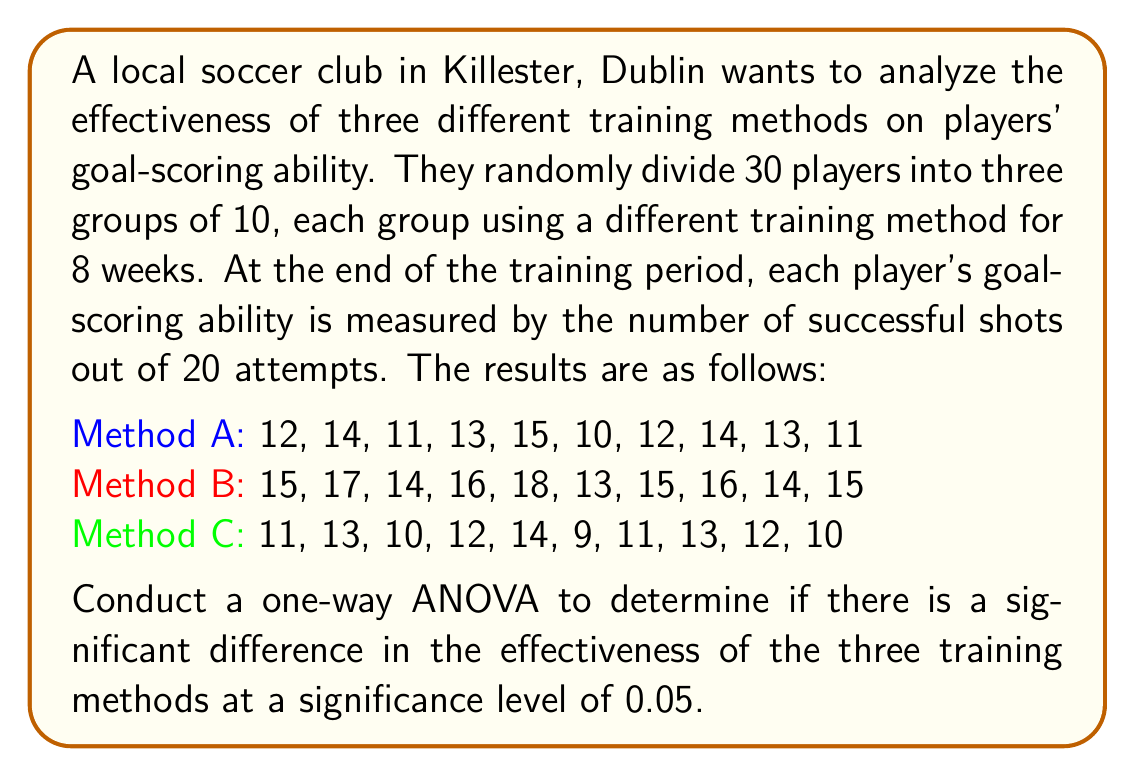What is the answer to this math problem? To conduct a one-way ANOVA, we'll follow these steps:

1. Calculate the sum of squares between groups (SSB), within groups (SSW), and total (SST).
2. Calculate the degrees of freedom for between groups (dfB), within groups (dfW), and total (dfT).
3. Calculate the mean squares for between groups (MSB) and within groups (MSW).
4. Calculate the F-statistic.
5. Compare the F-statistic to the critical F-value.

Step 1: Calculate sums of squares

First, we need to calculate the grand mean:
$$ \bar{X} = \frac{(12+14+...+10) + (15+17+...+15) + (11+13+...+10)}{30} = 13.3 $$

Now, we can calculate SSB, SSW, and SST:

SSB:
$$ SSB = 10[(12.5-13.3)^2 + (15.3-13.3)^2 + (11.5-13.3)^2] = 90.2 $$

SSW:
$$ SSW = [(12-12.5)^2 + (14-12.5)^2 + ... + (10-11.5)^2] = 88.6 $$

SST:
$$ SST = SSB + SSW = 90.2 + 88.6 = 178.8 $$

Step 2: Calculate degrees of freedom

$$ df_B = 3 - 1 = 2 $$
$$ df_W = 30 - 3 = 27 $$
$$ df_T = 30 - 1 = 29 $$

Step 3: Calculate mean squares

$$ MSB = \frac{SSB}{df_B} = \frac{90.2}{2} = 45.1 $$
$$ MSW = \frac{SSW}{df_W} = \frac{88.6}{27} = 3.28 $$

Step 4: Calculate F-statistic

$$ F = \frac{MSB}{MSW} = \frac{45.1}{3.28} = 13.75 $$

Step 5: Compare F-statistic to critical F-value

The critical F-value for $\alpha = 0.05$, $df_B = 2$, and $df_W = 27$ is approximately 3.35.

Since our calculated F-statistic (13.75) is greater than the critical F-value (3.35), we reject the null hypothesis.
Answer: The one-way ANOVA results show a significant difference in the effectiveness of the three training methods (F(2,27) = 13.75, p < 0.05). We reject the null hypothesis and conclude that at least one of the training methods has a significantly different effect on players' goal-scoring ability. 